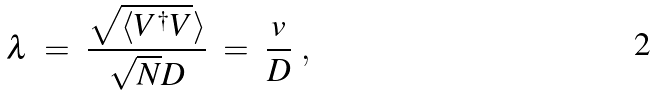<formula> <loc_0><loc_0><loc_500><loc_500>\lambda \ = \ \frac { \sqrt { \langle V ^ { \dagger } V } \rangle } { \sqrt { N } D } \ = \ \frac { v } { D } \ ,</formula> 